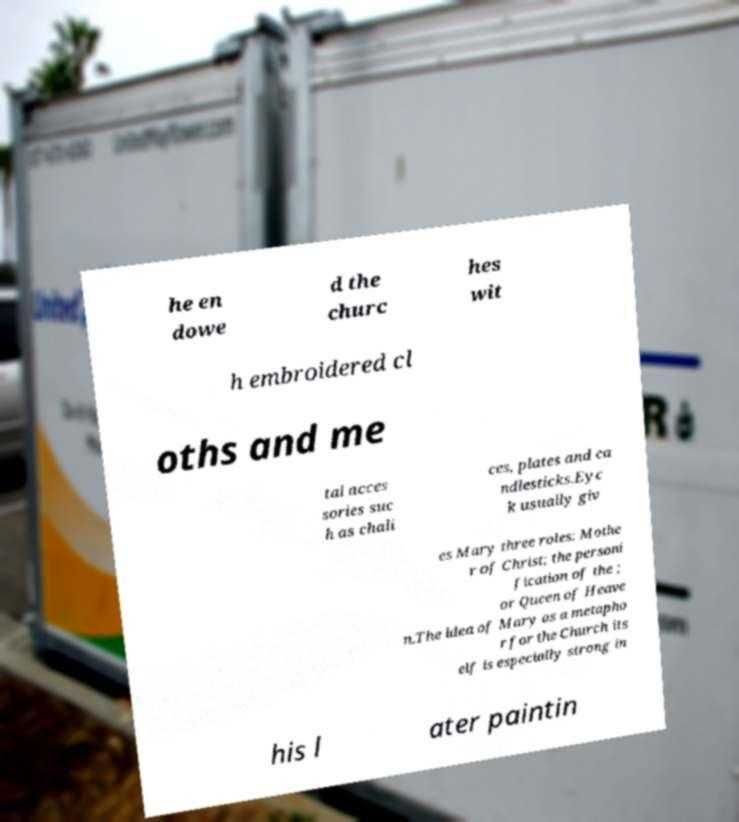For documentation purposes, I need the text within this image transcribed. Could you provide that? he en dowe d the churc hes wit h embroidered cl oths and me tal acces sories suc h as chali ces, plates and ca ndlesticks.Eyc k usually giv es Mary three roles: Mothe r of Christ; the personi fication of the ; or Queen of Heave n.The idea of Mary as a metapho r for the Church its elf is especially strong in his l ater paintin 